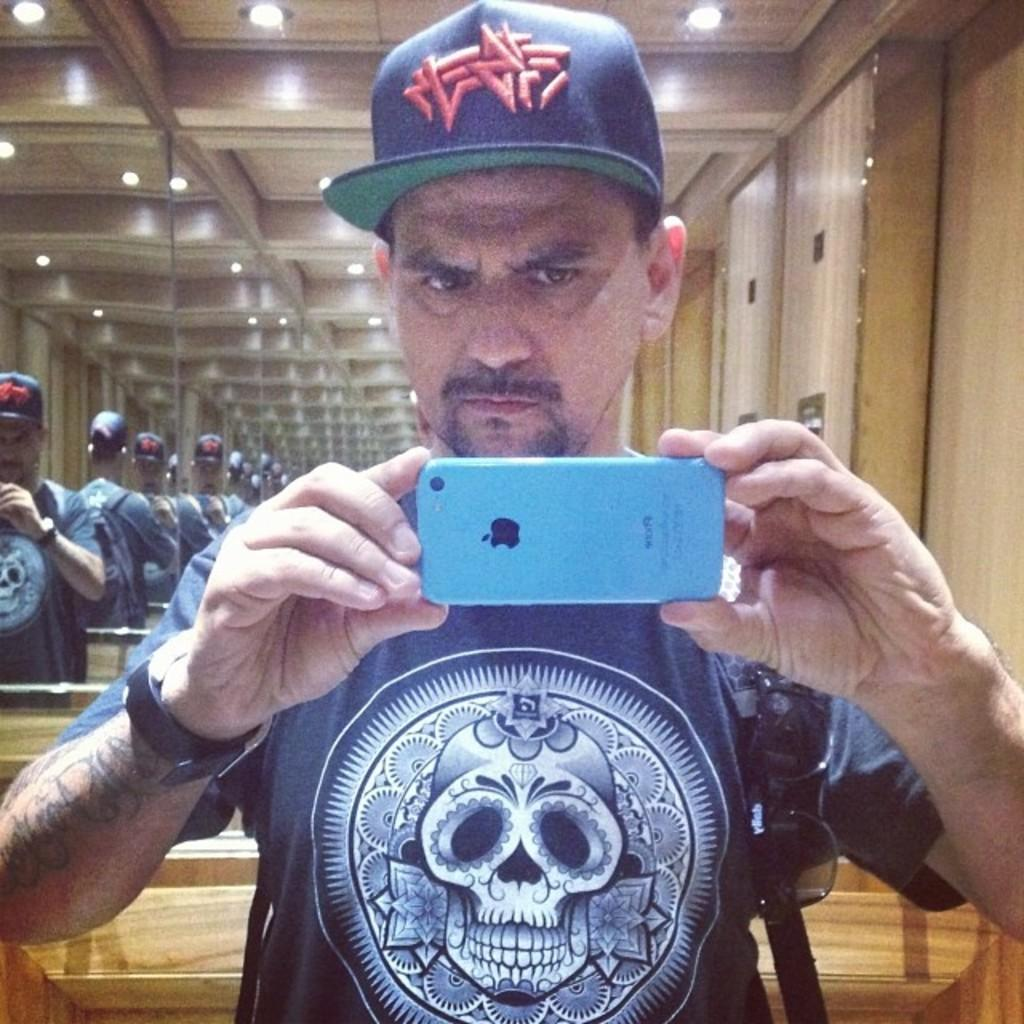What is the main subject in the foreground of the image? There is a man in the foreground of the image. What is the man holding in the image? The man is holding a camera. What is the man wearing in the image? The man is wearing a bag. What can be seen in the background of the image? There are mirrors, lights, and a wooden wall in the background of the image. What type of songs can be heard playing in the background of the image? There is no audio or music present in the image, so it is not possible to determine what songs might be heard. 